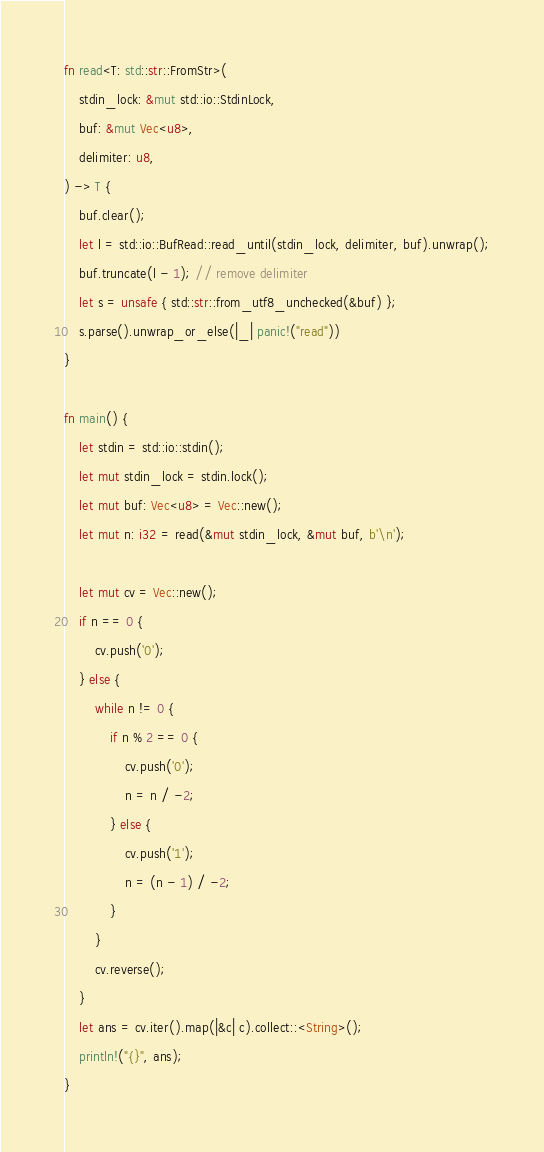<code> <loc_0><loc_0><loc_500><loc_500><_Rust_>fn read<T: std::str::FromStr>(
    stdin_lock: &mut std::io::StdinLock,
    buf: &mut Vec<u8>,
    delimiter: u8,
) -> T {
    buf.clear();
    let l = std::io::BufRead::read_until(stdin_lock, delimiter, buf).unwrap();
    buf.truncate(l - 1); // remove delimiter
    let s = unsafe { std::str::from_utf8_unchecked(&buf) };
    s.parse().unwrap_or_else(|_| panic!("read"))
}

fn main() {
    let stdin = std::io::stdin();
    let mut stdin_lock = stdin.lock();
    let mut buf: Vec<u8> = Vec::new();
    let mut n: i32 = read(&mut stdin_lock, &mut buf, b'\n');

    let mut cv = Vec::new();
    if n == 0 {
        cv.push('0');
    } else {
        while n != 0 {
            if n % 2 == 0 {
                cv.push('0');
                n = n / -2;
            } else {
                cv.push('1');
                n = (n - 1) / -2;
            }
        }
        cv.reverse();
    }
    let ans = cv.iter().map(|&c| c).collect::<String>();
    println!("{}", ans);
}
</code> 